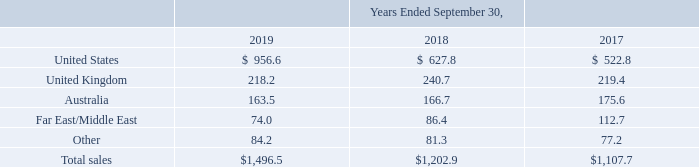Disaggregation of Total Net Sales: We disaggregate our sales from contracts with customers by end customer, contract type, deliverable type and revenue recognition method for each of our segments, as we believe these factors affect the nature, amount, timing, and uncertainty of our revenue and cash flows.
Sales by Geographic Region (in millions):
How does the company disaggregate its sales from contracts with customers? By end customer, contract type, deliverable type and revenue recognition method for each of our segments. What is the amount of total sales in 2017?
Answer scale should be: million. $1,107.7. What are the different geographic regions in the table? United states, united kingdom, australia, far east/middle east, other. In which year was the amount of sales in Other the largest? 84.2>81.3>77.2
Answer: 2019. What is the change in the amount of Other in 2019 from 2018?
Answer scale should be: million. 84.2-81.3
Answer: 2.9. What is the percentage change in the amount of Other in 2019 from 2018?
Answer scale should be: percent. (84.2-81.3)/81.3
Answer: 3.57. 